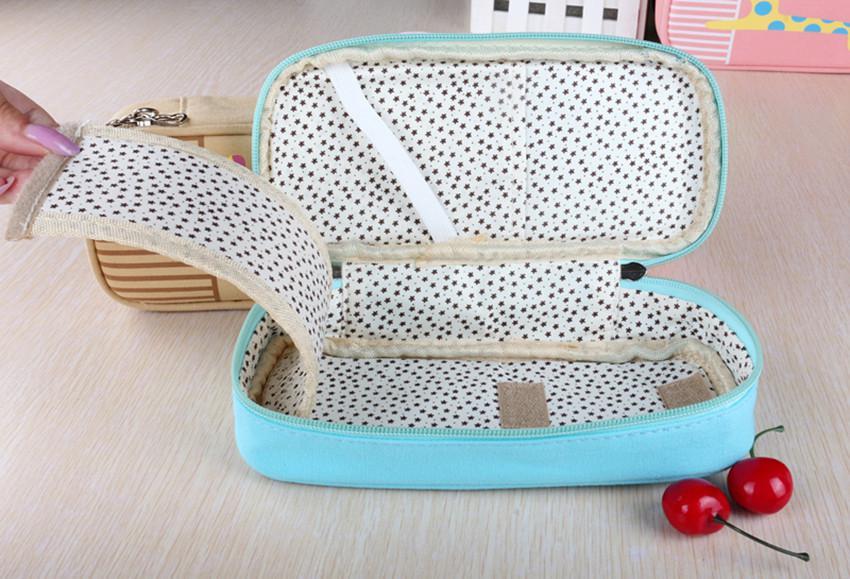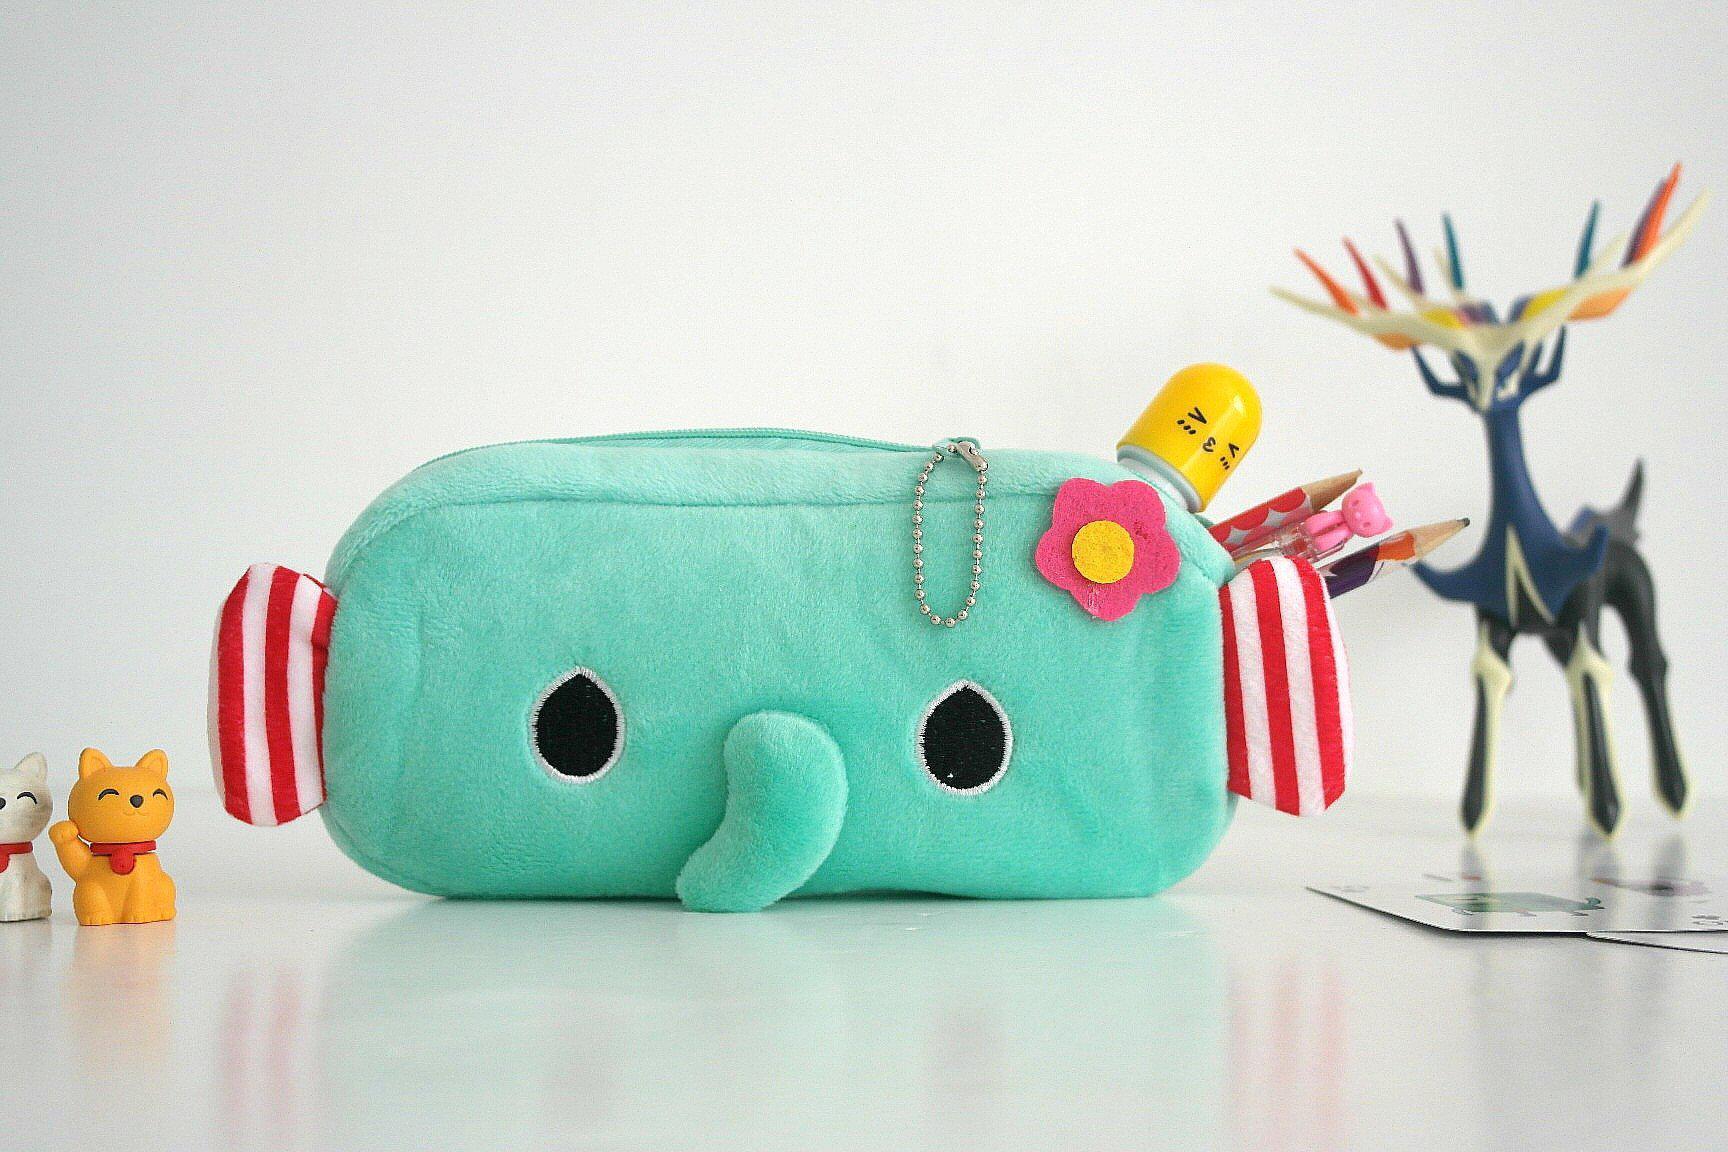The first image is the image on the left, the second image is the image on the right. Evaluate the accuracy of this statement regarding the images: "One image shows just one pencil case, which has eyes.". Is it true? Answer yes or no. Yes. 